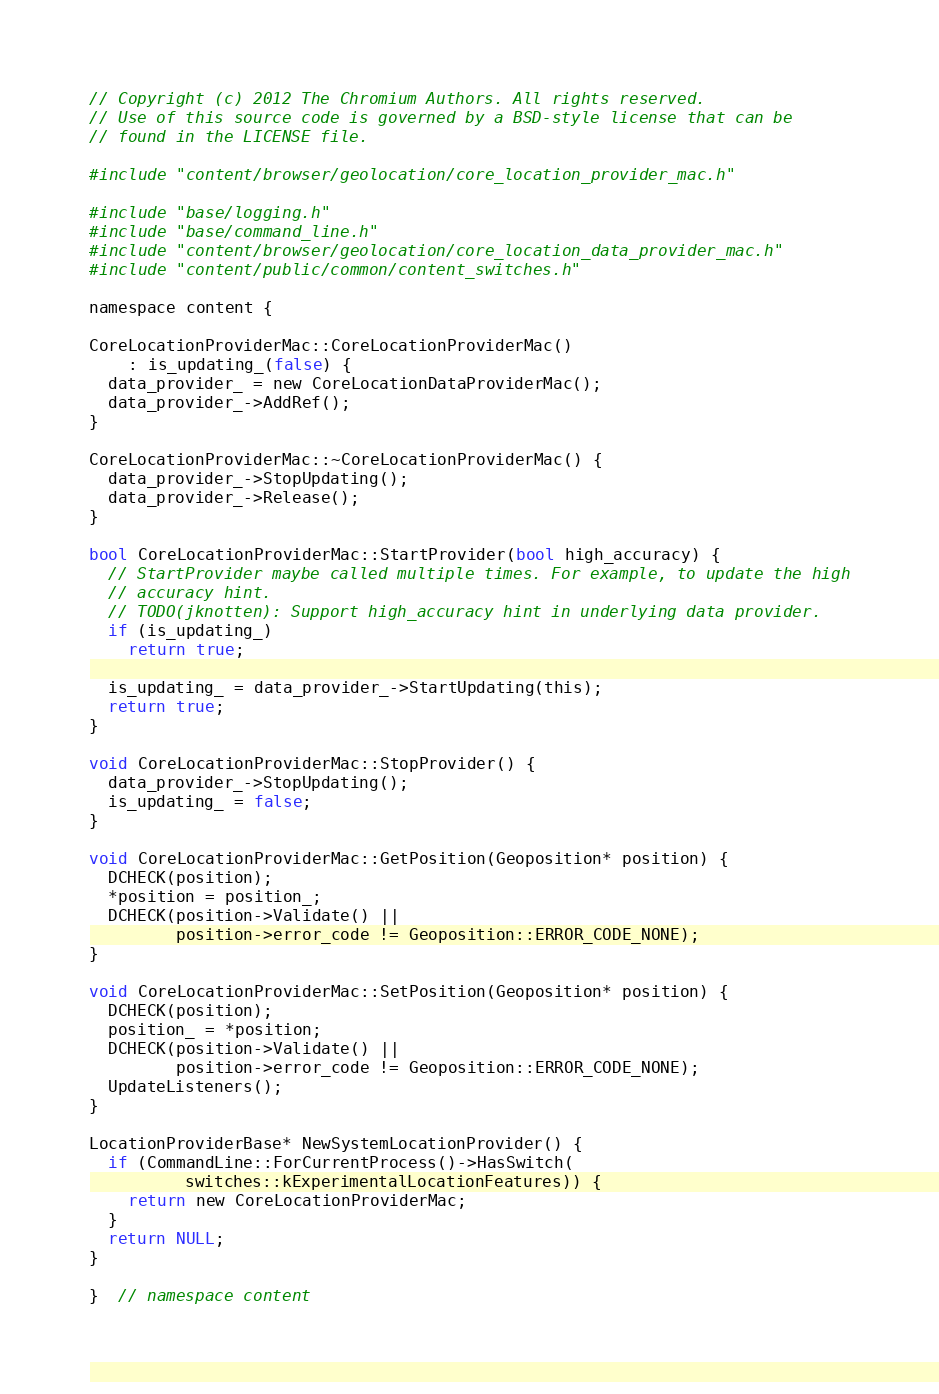<code> <loc_0><loc_0><loc_500><loc_500><_ObjectiveC_>// Copyright (c) 2012 The Chromium Authors. All rights reserved.
// Use of this source code is governed by a BSD-style license that can be
// found in the LICENSE file.

#include "content/browser/geolocation/core_location_provider_mac.h"

#include "base/logging.h"
#include "base/command_line.h"
#include "content/browser/geolocation/core_location_data_provider_mac.h"
#include "content/public/common/content_switches.h"

namespace content {

CoreLocationProviderMac::CoreLocationProviderMac()
    : is_updating_(false) {
  data_provider_ = new CoreLocationDataProviderMac();
  data_provider_->AddRef();
}

CoreLocationProviderMac::~CoreLocationProviderMac() {
  data_provider_->StopUpdating();
  data_provider_->Release();
}

bool CoreLocationProviderMac::StartProvider(bool high_accuracy) {
  // StartProvider maybe called multiple times. For example, to update the high
  // accuracy hint.
  // TODO(jknotten): Support high_accuracy hint in underlying data provider.
  if (is_updating_)
    return true;

  is_updating_ = data_provider_->StartUpdating(this);
  return true;
}

void CoreLocationProviderMac::StopProvider() {
  data_provider_->StopUpdating();
  is_updating_ = false;
}

void CoreLocationProviderMac::GetPosition(Geoposition* position) {
  DCHECK(position);
  *position = position_;
  DCHECK(position->Validate() ||
         position->error_code != Geoposition::ERROR_CODE_NONE);
}

void CoreLocationProviderMac::SetPosition(Geoposition* position) {
  DCHECK(position);
  position_ = *position;
  DCHECK(position->Validate() ||
         position->error_code != Geoposition::ERROR_CODE_NONE);
  UpdateListeners();
}

LocationProviderBase* NewSystemLocationProvider() {
  if (CommandLine::ForCurrentProcess()->HasSwitch(
          switches::kExperimentalLocationFeatures)) {
    return new CoreLocationProviderMac;
  }
  return NULL;
}

}  // namespace content
</code> 